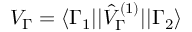Convert formula to latex. <formula><loc_0><loc_0><loc_500><loc_500>V _ { \Gamma } = \langle \Gamma _ { 1 } | | \hat { V } _ { \Gamma } ^ { ( 1 ) } | | \Gamma _ { 2 } \rangle</formula> 